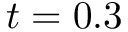<formula> <loc_0><loc_0><loc_500><loc_500>t = 0 . 3</formula> 